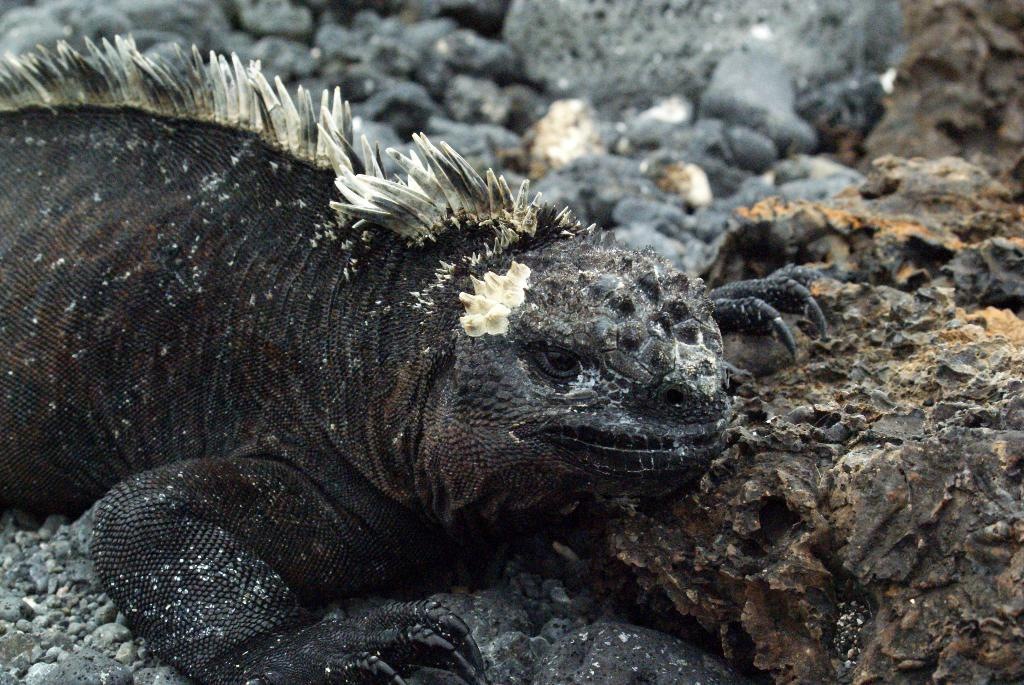What type of animal is in the image? The animal in the image is black and white in color. What other elements can be seen in the image besides the animal? There are rocks and stones in the image. How would you describe the background of the image? The background of the image is slightly blurred. What type of war is being fought in the background of the image? There is no war present in the image; it only features an animal, rocks and stones, and a slightly blurred background. 